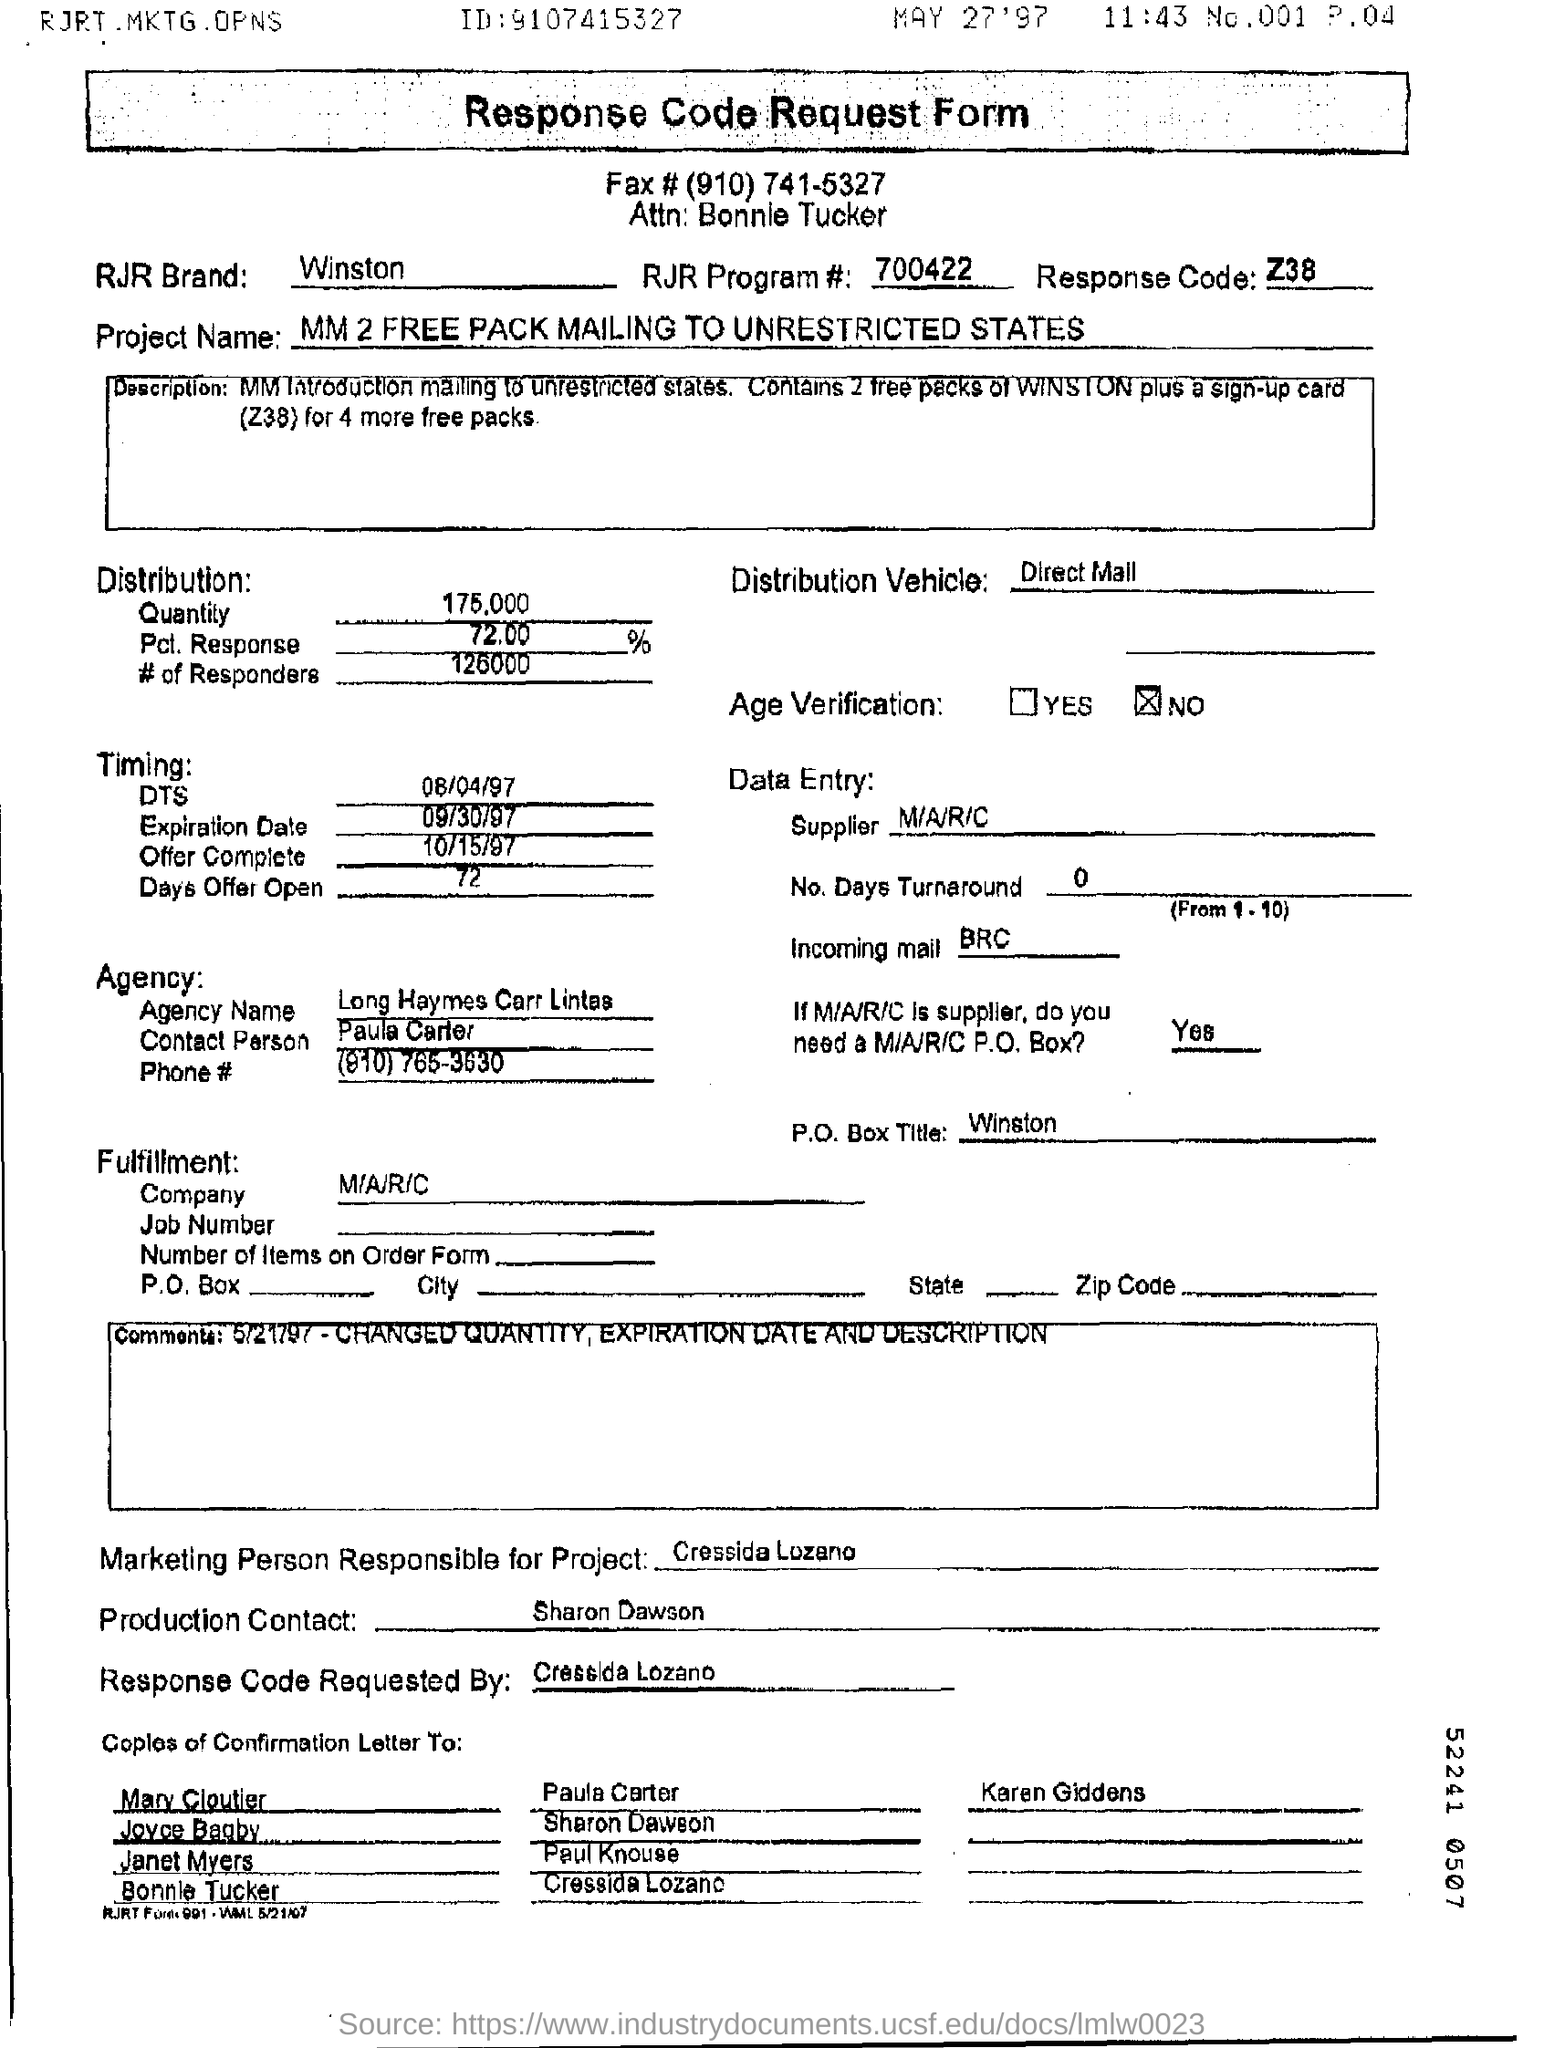Indicate a few pertinent items in this graphic. The individual responsible for this project is Cressida Lozano. The response code is Z38.. The RJR Program# mentioned in the form is 700422... The quantity of the distribution is 175,000. 